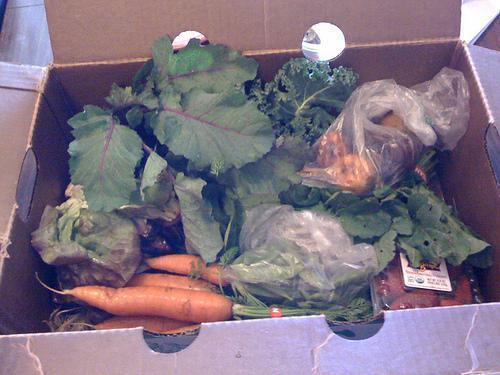How many carrots are in the box?
Give a very brief answer. 4. 